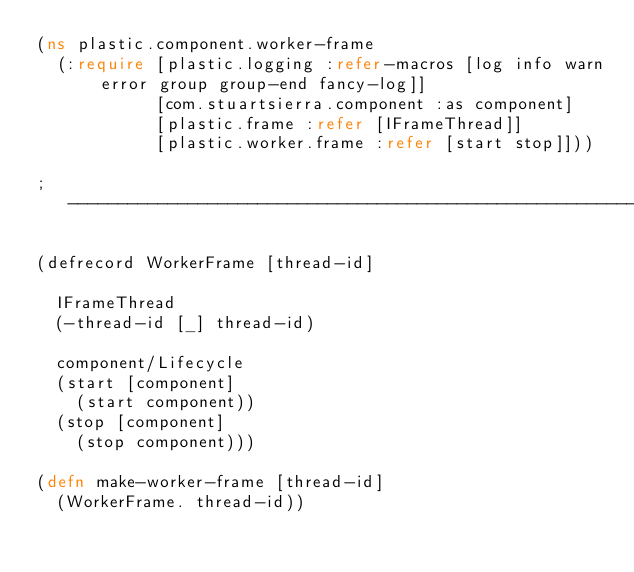<code> <loc_0><loc_0><loc_500><loc_500><_Clojure_>(ns plastic.component.worker-frame
  (:require [plastic.logging :refer-macros [log info warn error group group-end fancy-log]]
            [com.stuartsierra.component :as component]
            [plastic.frame :refer [IFrameThread]]
            [plastic.worker.frame :refer [start stop]]))

; -------------------------------------------------------------------------------------------------------------------

(defrecord WorkerFrame [thread-id]

  IFrameThread
  (-thread-id [_] thread-id)

  component/Lifecycle
  (start [component]
    (start component))
  (stop [component]
    (stop component)))

(defn make-worker-frame [thread-id]
  (WorkerFrame. thread-id))</code> 